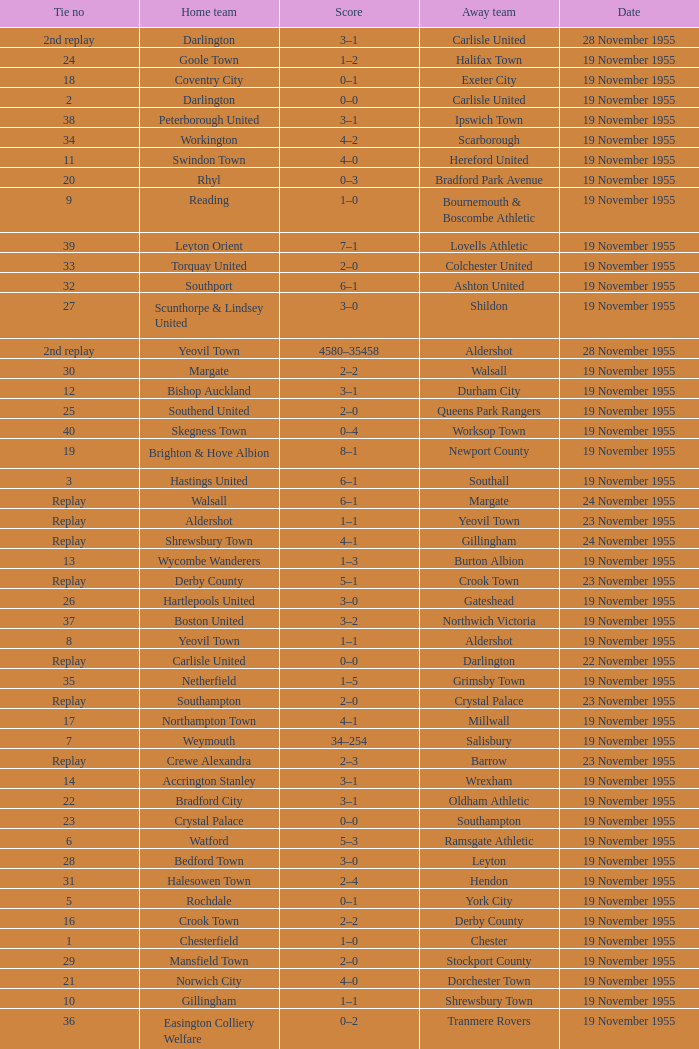What is the away team with a 5 tie no? York City. 